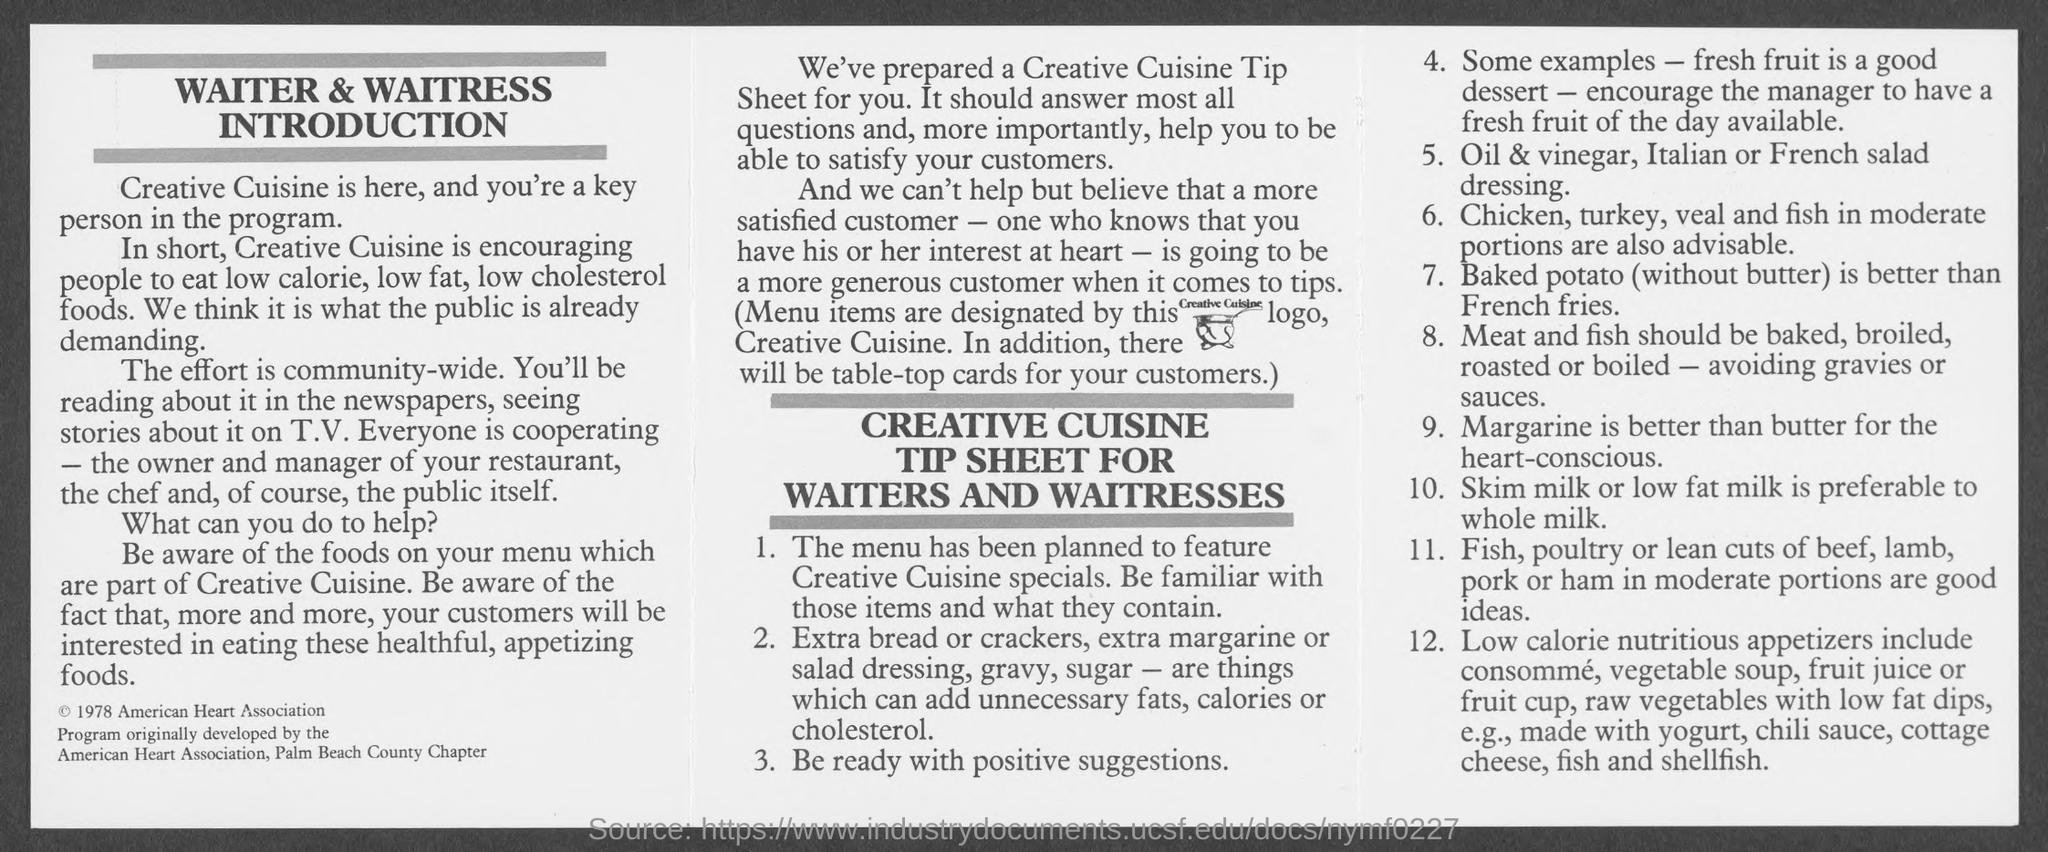Indicate a few pertinent items in this graphic. Skim milk or low fat milk is considered to be the preferable type of milk. Vegetable soup, consomme, and fruit juices are categorized under Low Calorie Nutritious Appetizers. 